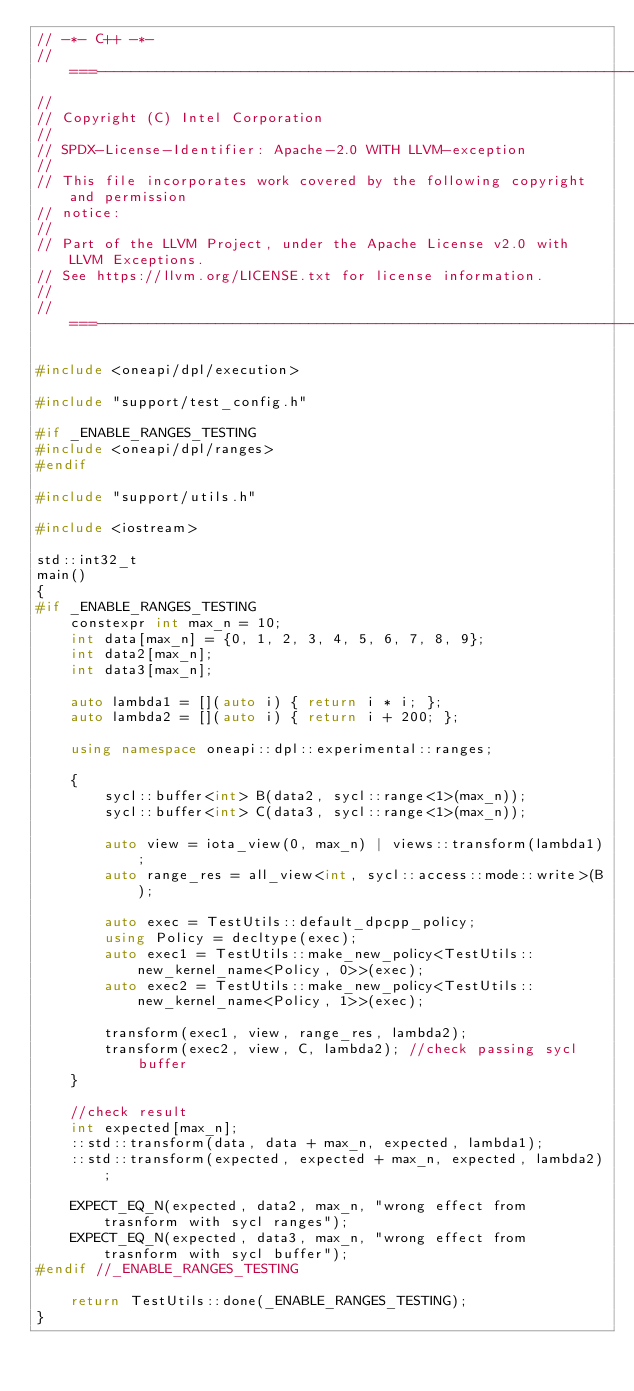<code> <loc_0><loc_0><loc_500><loc_500><_C++_>// -*- C++ -*-
//===----------------------------------------------------------------------===//
//
// Copyright (C) Intel Corporation
//
// SPDX-License-Identifier: Apache-2.0 WITH LLVM-exception
//
// This file incorporates work covered by the following copyright and permission
// notice:
//
// Part of the LLVM Project, under the Apache License v2.0 with LLVM Exceptions.
// See https://llvm.org/LICENSE.txt for license information.
//
//===----------------------------------------------------------------------===//

#include <oneapi/dpl/execution>

#include "support/test_config.h"

#if _ENABLE_RANGES_TESTING
#include <oneapi/dpl/ranges>
#endif

#include "support/utils.h"

#include <iostream>

std::int32_t
main()
{
#if _ENABLE_RANGES_TESTING
    constexpr int max_n = 10;
    int data[max_n] = {0, 1, 2, 3, 4, 5, 6, 7, 8, 9};
    int data2[max_n];
    int data3[max_n];

    auto lambda1 = [](auto i) { return i * i; };
    auto lambda2 = [](auto i) { return i + 200; };

    using namespace oneapi::dpl::experimental::ranges;

    {
        sycl::buffer<int> B(data2, sycl::range<1>(max_n));
        sycl::buffer<int> C(data3, sycl::range<1>(max_n));

        auto view = iota_view(0, max_n) | views::transform(lambda1);
        auto range_res = all_view<int, sycl::access::mode::write>(B);

        auto exec = TestUtils::default_dpcpp_policy;
        using Policy = decltype(exec);
        auto exec1 = TestUtils::make_new_policy<TestUtils::new_kernel_name<Policy, 0>>(exec);
        auto exec2 = TestUtils::make_new_policy<TestUtils::new_kernel_name<Policy, 1>>(exec);

        transform(exec1, view, range_res, lambda2);
        transform(exec2, view, C, lambda2); //check passing sycl buffer
    }

    //check result
    int expected[max_n];
    ::std::transform(data, data + max_n, expected, lambda1);
    ::std::transform(expected, expected + max_n, expected, lambda2);

    EXPECT_EQ_N(expected, data2, max_n, "wrong effect from trasnform with sycl ranges");
    EXPECT_EQ_N(expected, data3, max_n, "wrong effect from trasnform with sycl buffer");
#endif //_ENABLE_RANGES_TESTING

    return TestUtils::done(_ENABLE_RANGES_TESTING);
}
</code> 